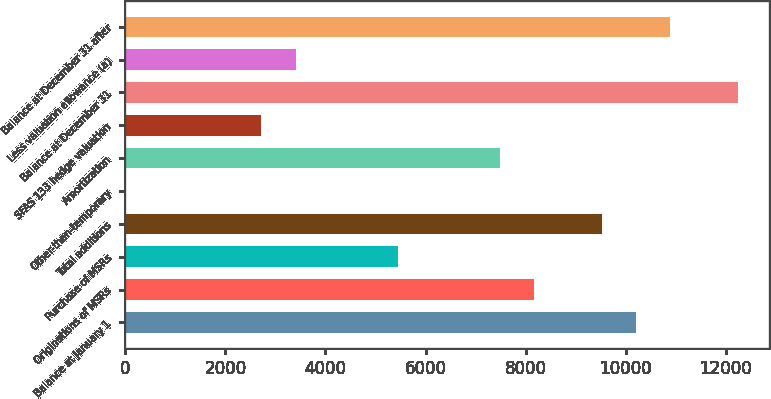Convert chart. <chart><loc_0><loc_0><loc_500><loc_500><bar_chart><fcel>Balance at January 1<fcel>Originations of MSRs<fcel>Purchase of MSRs<fcel>Total additions<fcel>Other-than-temporary<fcel>Amortization<fcel>SFAS 133 hedge valuation<fcel>Balance at December 31<fcel>Less valuation allowance (a)<fcel>Balance at December 31 after<nl><fcel>10202.5<fcel>8162.2<fcel>5441.8<fcel>9522.4<fcel>1<fcel>7482.1<fcel>2721.4<fcel>12242.8<fcel>3401.5<fcel>10882.6<nl></chart> 